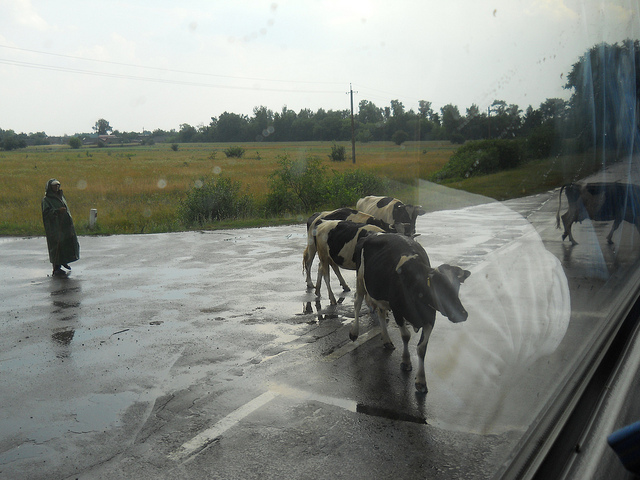<image>What is cast? It is not certain what is cast. It could be cows, the reflection of something, light on puddles, or even clouds. What is cast? I am not sure what the cast is. It can be cows, reflection, sky, light on puddles, clouds, or cow. 